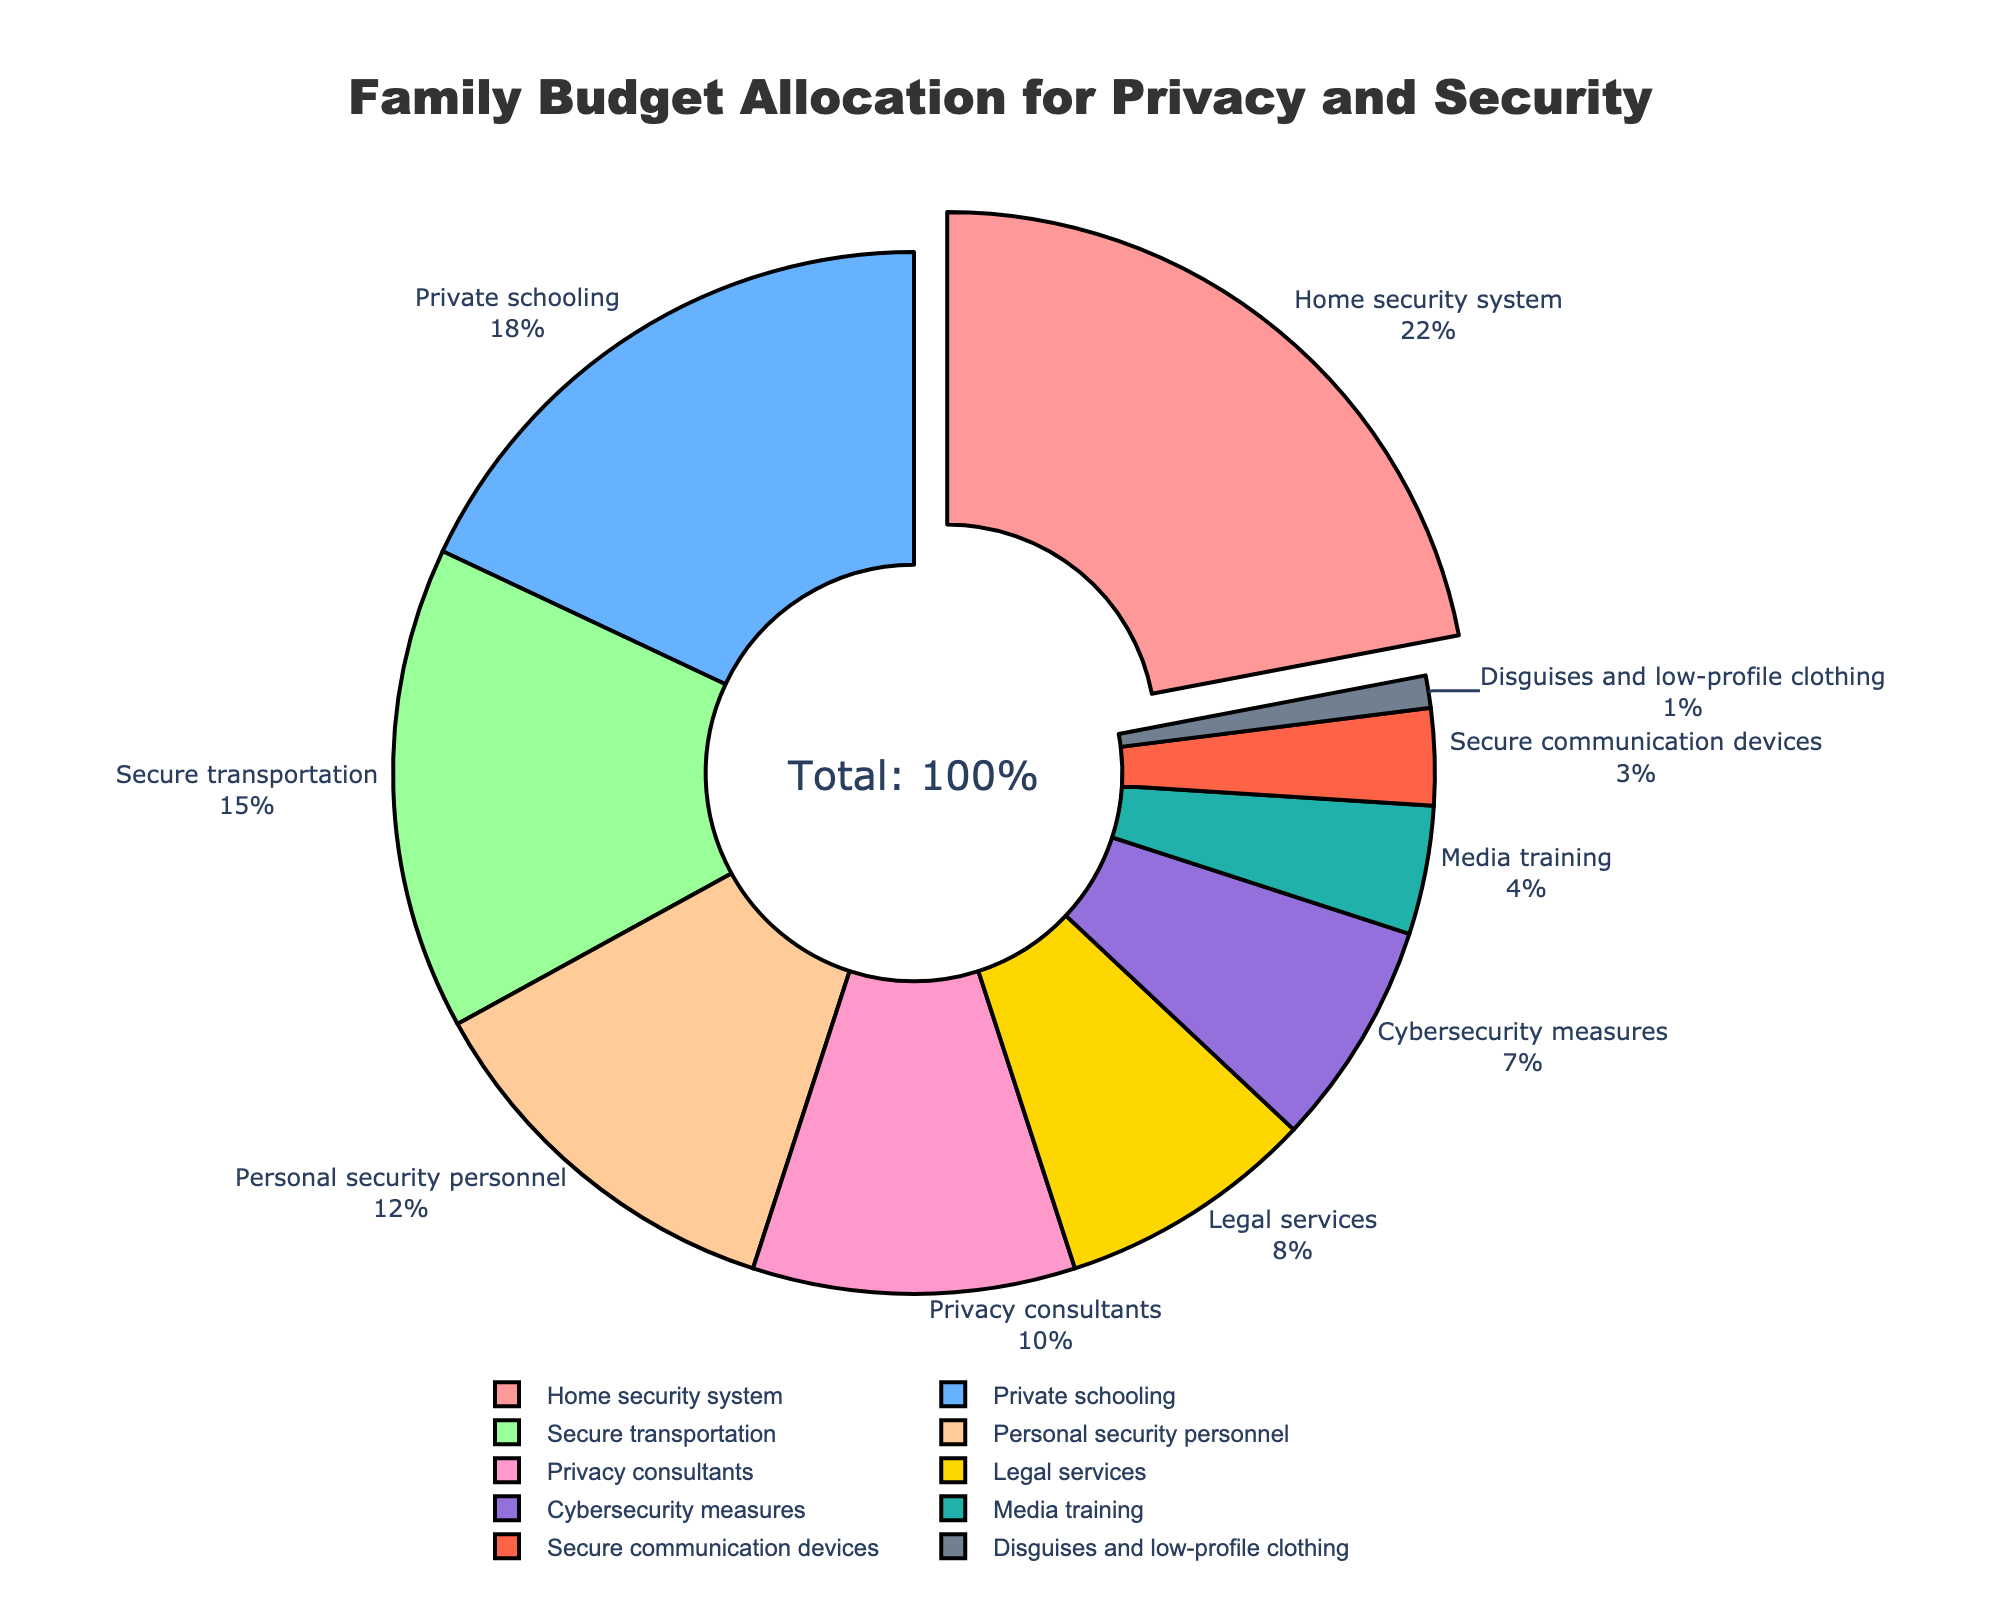Which category has the largest allocation in the budget? The segment of the pie chart that appears to be the largest is for Home security system, which also has a pull-out effect highlighting it.
Answer: Home security system What percentage of the budget is allocated to secure communication devices? The label "Secure communication devices" shows the percentage allocation, which is 3%.
Answer: 3% Which category has a higher allocation: private schooling or personal security personnel? By comparing the slices in the pie chart, the label for Private schooling shows 18%, while the label for Personal security personnel shows 12%. 18% is greater than 12%.
Answer: Private schooling Is the allocation for cybersecurity measures greater than the allocation for legal services? The pie chart shows 7% for Cybersecurity measures and 8% for Legal services. Since 7% is less than 8%, the allocation for cybersecurity measures is not greater.
Answer: No What is the total allocation percentage for categories related to personnel (personal security personnel and privacy consultants)? Adding the percentages for Personal security personnel (12%) and Privacy consultants (10%), we get 12% + 10% = 22%.
Answer: 22% How much more is allocated to secure transportation compared to media training? Secure transportation has 15% while media training has 4%. The difference is 15% - 4% = 11%.
Answer: 11% Which category has the smallest allocation? The smallest segment in the pie chart is labeled "Disguises and low-profile clothing" with 1%.
Answer: Disguises and low-profile clothing What is the combined percentage for categories related to security (home security system, secure transportation, personal security personnel, and cybersecurity measures)? Combining "Home security system" (22%), "Secure transportation" (15%), "Personal security personnel" (12%), and "Cybersecurity measures" (7%) gives 22% + 15% + 12% + 7% = 56%.
Answer: 56% Which category is allocated less than 10% of the budget and involves technology measures? The category involving technology measures that is allocated less than 10% is Cybersecurity measures, which shows 7% in the chart.
Answer: Cybersecurity measures What is the difference between the highest and the lowest allocation percentages? The highest allocation is for Home security system at 22% and the lowest is for Disguises and low-profile clothing at 1%. The difference is 22% - 1% = 21%.
Answer: 21% 